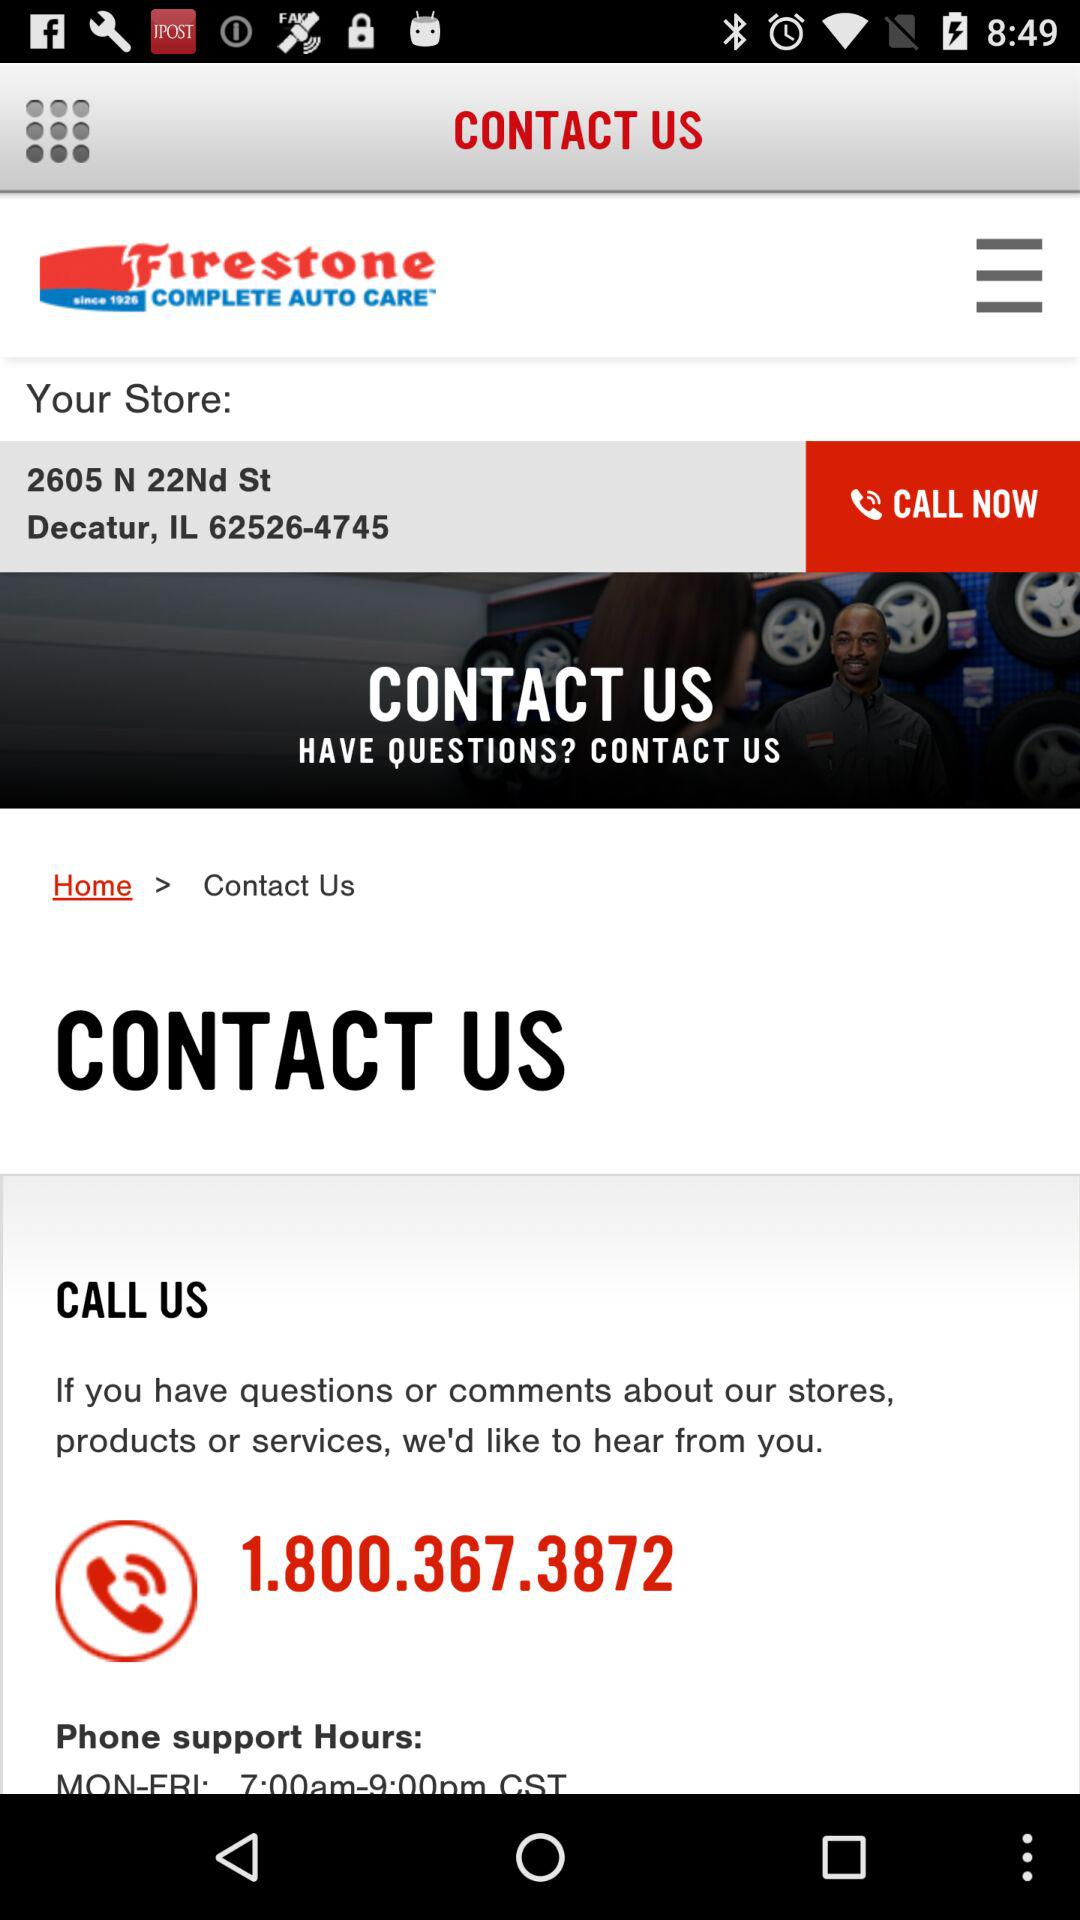What is the contact number? The contact number is 1.800.367.3872. 